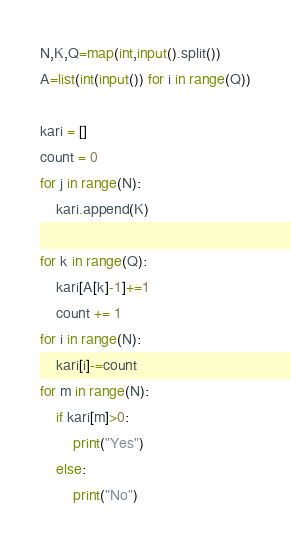<code> <loc_0><loc_0><loc_500><loc_500><_Python_>N,K,Q=map(int,input().split())
A=list(int(input()) for i in range(Q))

kari = []
count = 0
for j in range(N):
    kari.append(K)

for k in range(Q):
    kari[A[k]-1]+=1
    count += 1
for i in range(N):
    kari[i]-=count
for m in range(N):
    if kari[m]>0:
        print("Yes")
    else:
        print("No")</code> 